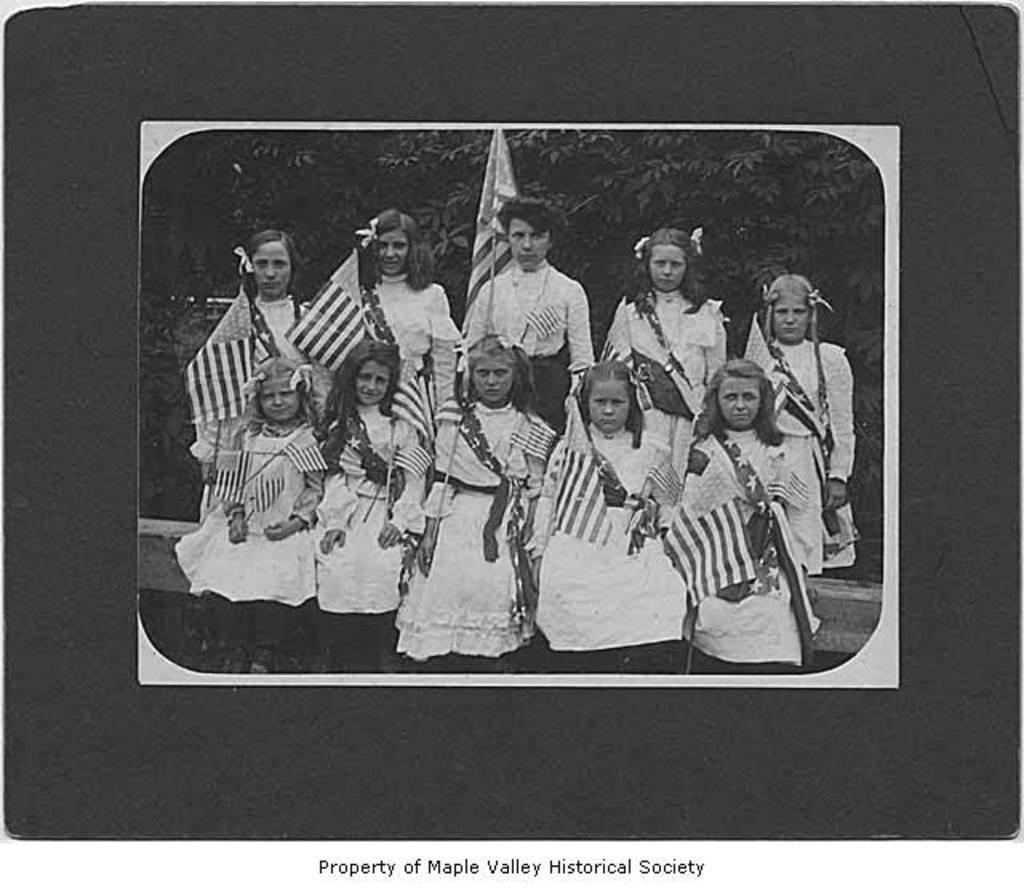In one or two sentences, can you explain what this image depicts? This is a black and white picture, there are many girls sitting and standing and they are holding flags, behind them there are trees. 